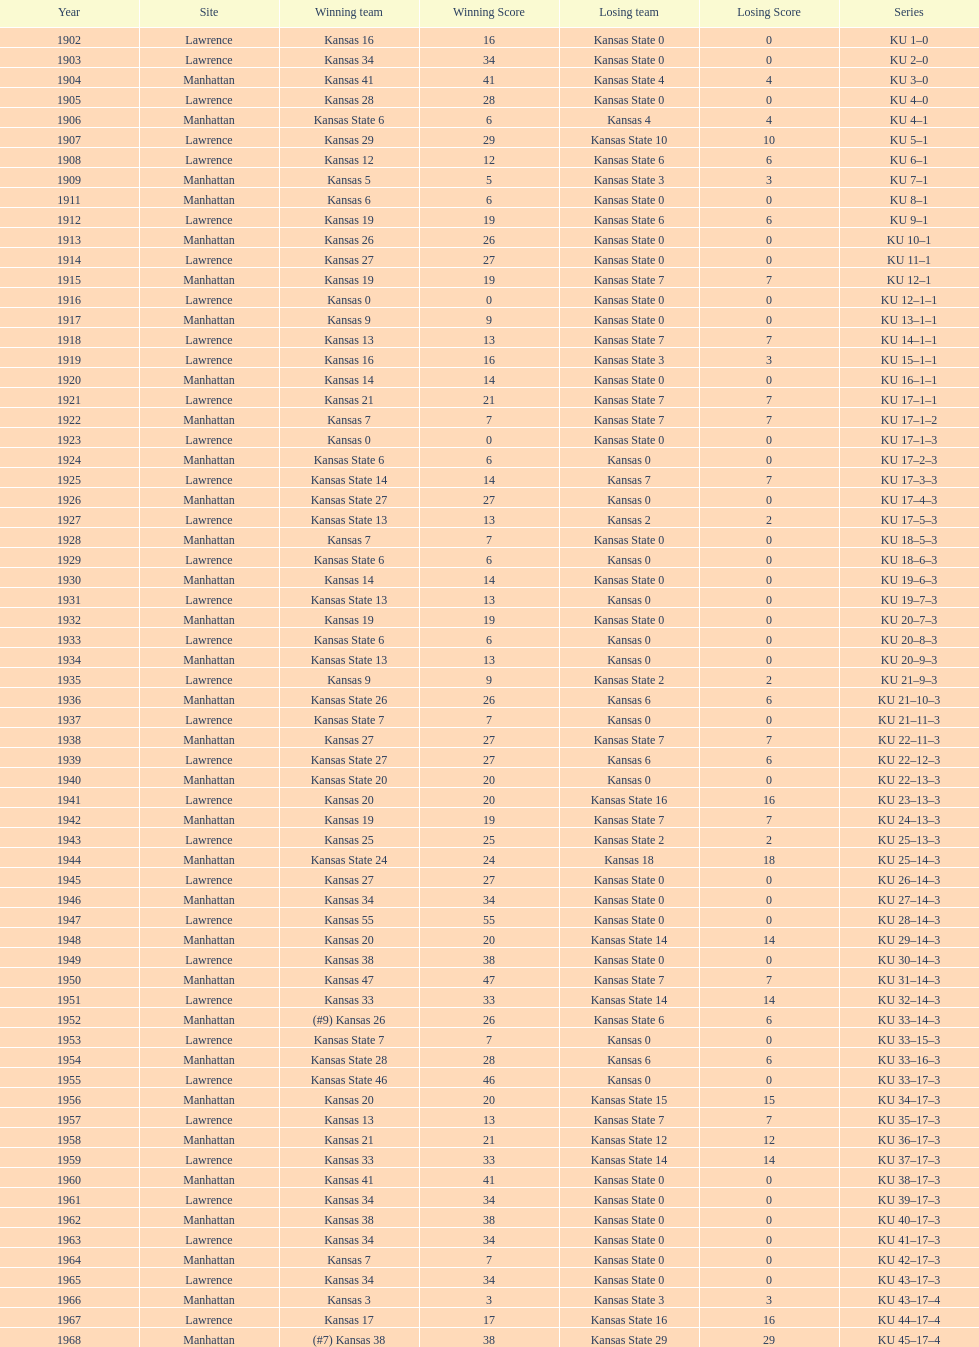What was the number of wins kansas state had in manhattan? 8. 